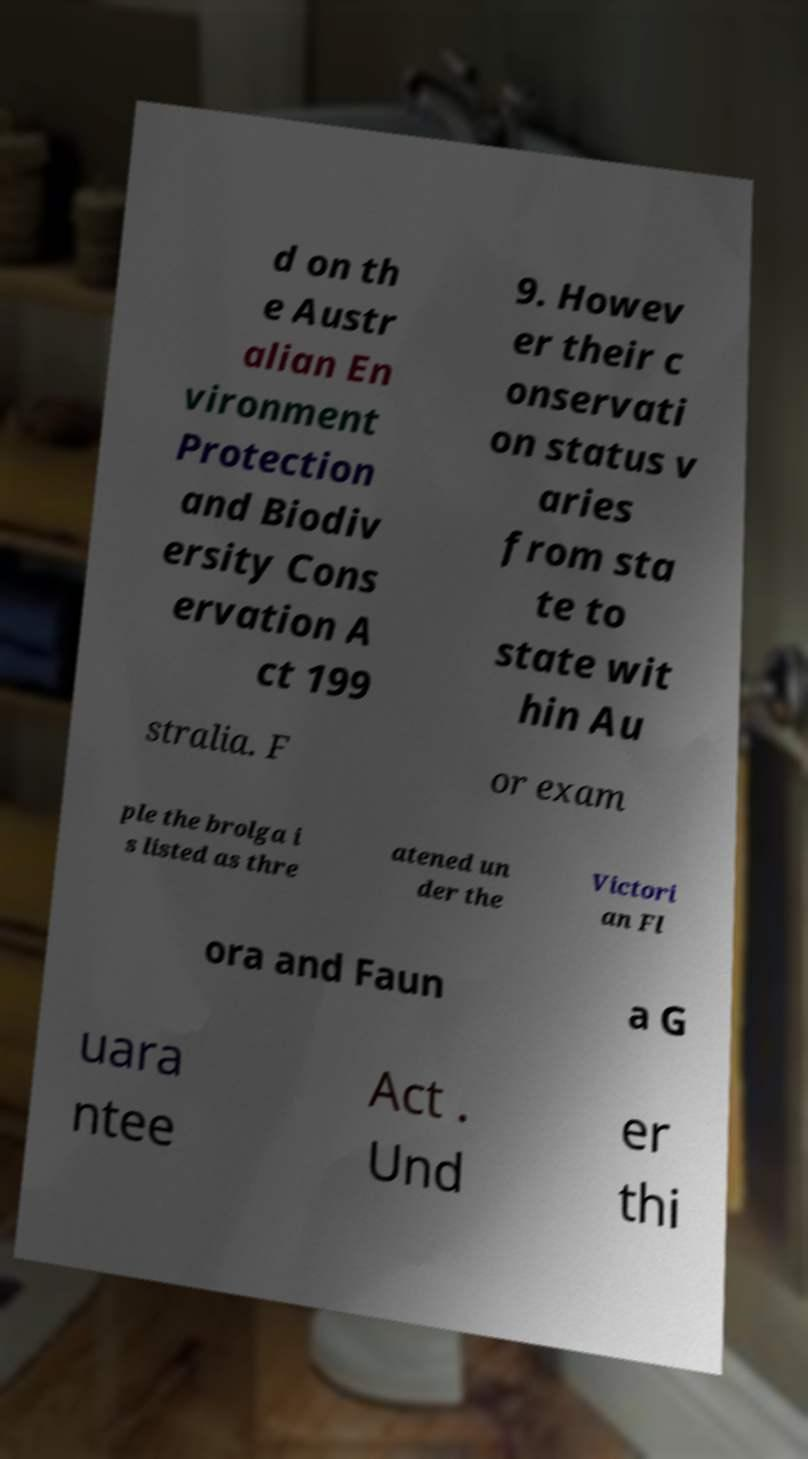Can you read and provide the text displayed in the image?This photo seems to have some interesting text. Can you extract and type it out for me? d on th e Austr alian En vironment Protection and Biodiv ersity Cons ervation A ct 199 9. Howev er their c onservati on status v aries from sta te to state wit hin Au stralia. F or exam ple the brolga i s listed as thre atened un der the Victori an Fl ora and Faun a G uara ntee Act . Und er thi 